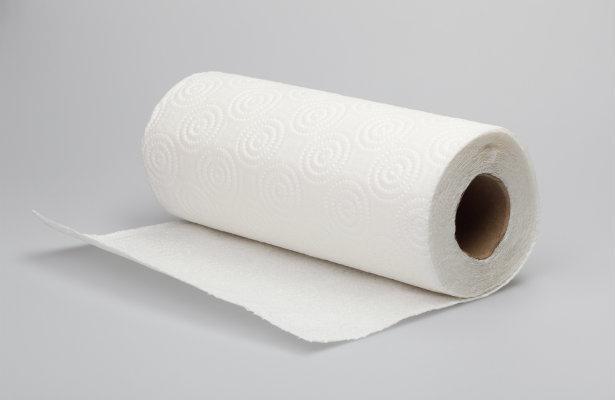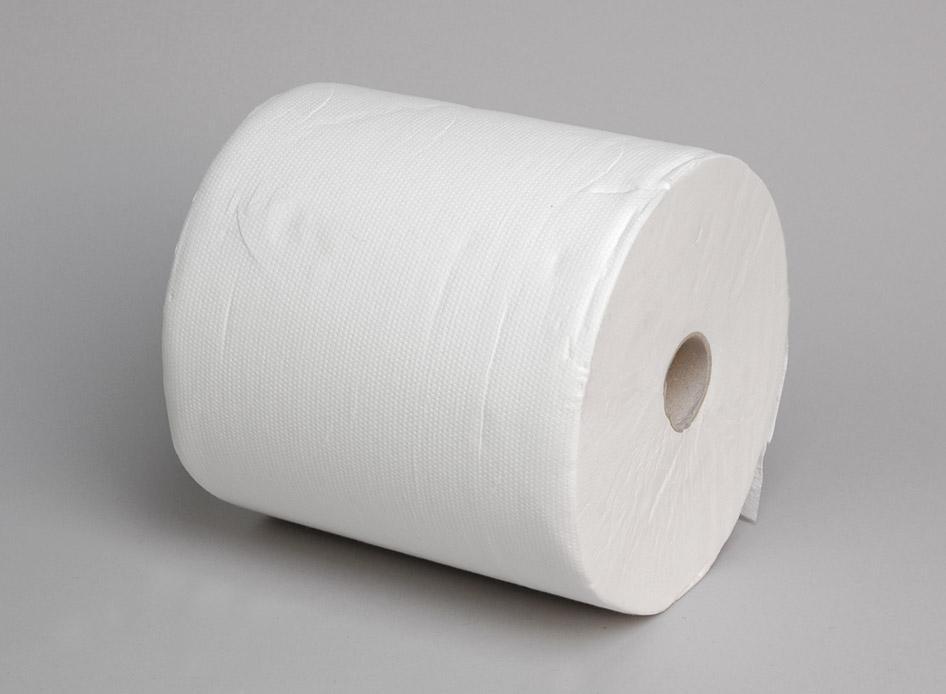The first image is the image on the left, the second image is the image on the right. Evaluate the accuracy of this statement regarding the images: "One of the images features a white, upright roll of paper towels". Is it true? Answer yes or no. No. 